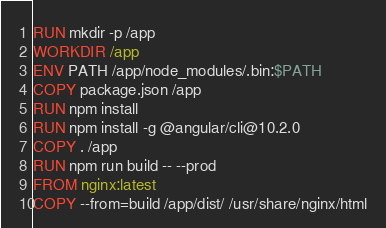<code> <loc_0><loc_0><loc_500><loc_500><_Dockerfile_>RUN mkdir -p /app
WORKDIR /app
ENV PATH /app/node_modules/.bin:$PATH
COPY package.json /app
RUN npm install
RUN npm install -g @angular/cli@10.2.0
COPY . /app
RUN npm run build -- --prod
FROM nginx:latest
COPY --from=build /app/dist/ /usr/share/nginx/html


</code> 